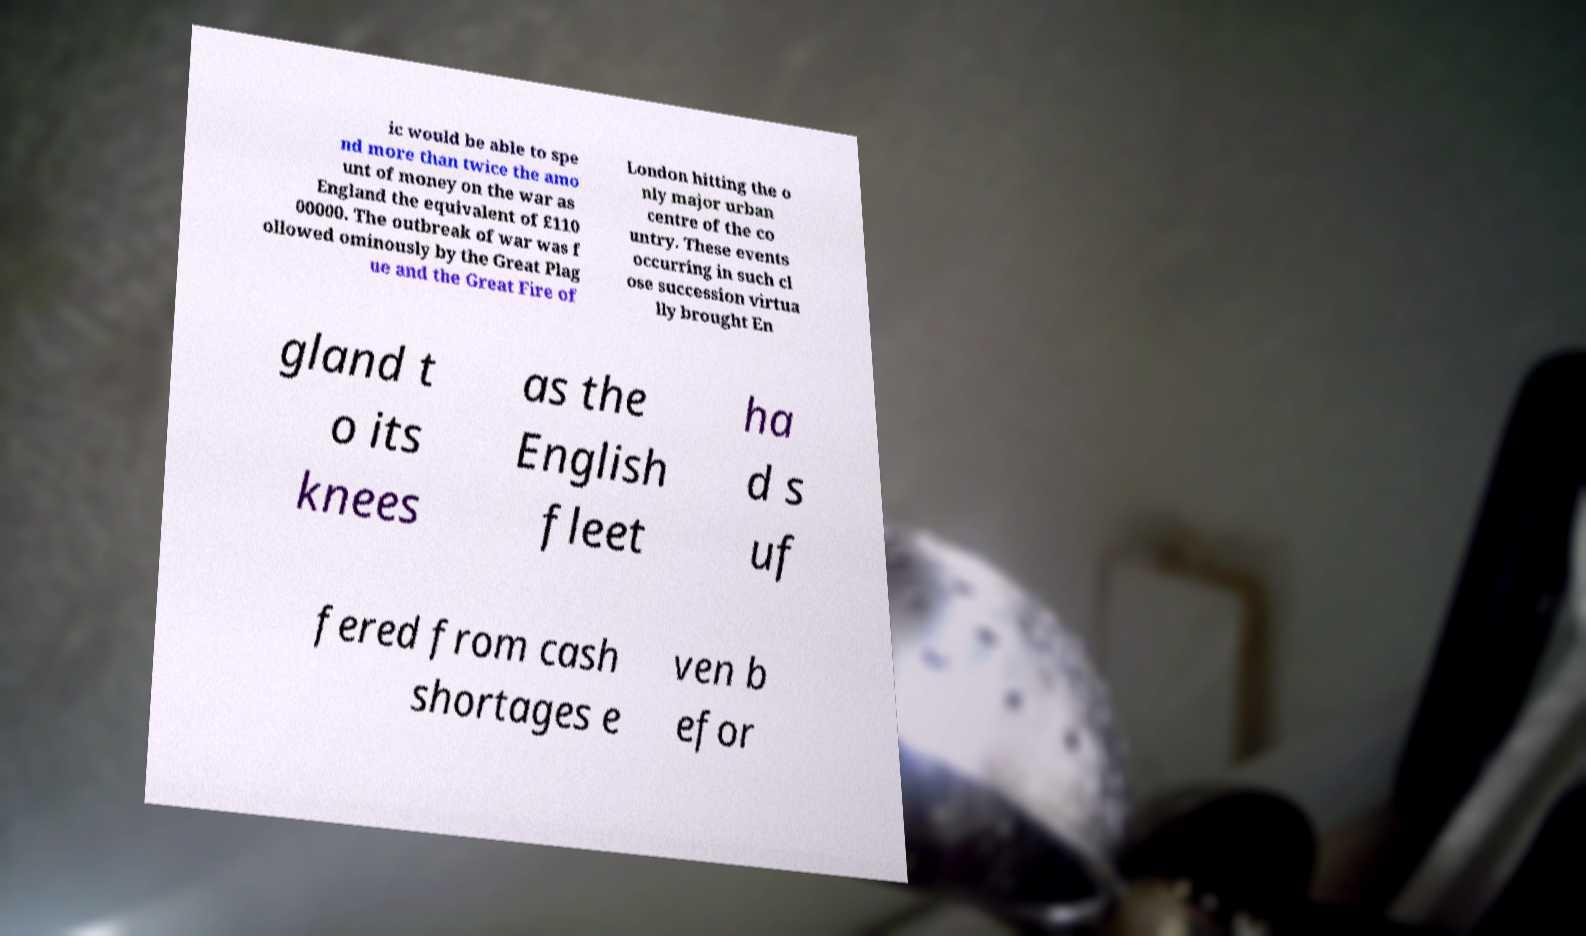I need the written content from this picture converted into text. Can you do that? ic would be able to spe nd more than twice the amo unt of money on the war as England the equivalent of £110 00000. The outbreak of war was f ollowed ominously by the Great Plag ue and the Great Fire of London hitting the o nly major urban centre of the co untry. These events occurring in such cl ose succession virtua lly brought En gland t o its knees as the English fleet ha d s uf fered from cash shortages e ven b efor 